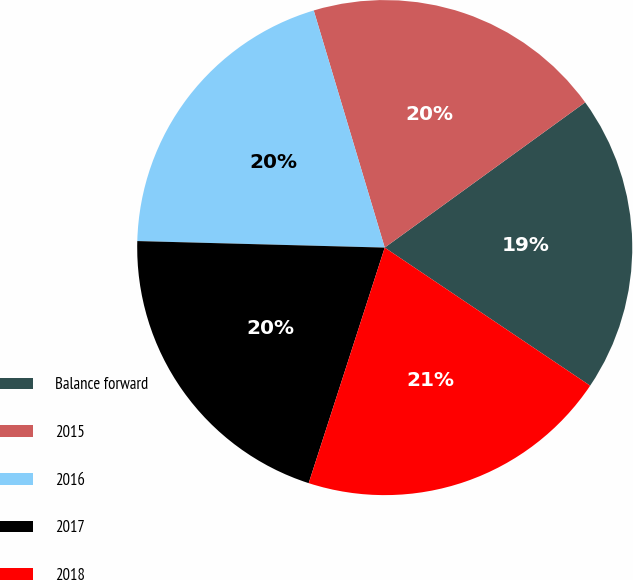<chart> <loc_0><loc_0><loc_500><loc_500><pie_chart><fcel>Balance forward<fcel>2015<fcel>2016<fcel>2017<fcel>2018<nl><fcel>19.4%<fcel>19.65%<fcel>19.95%<fcel>20.45%<fcel>20.55%<nl></chart> 